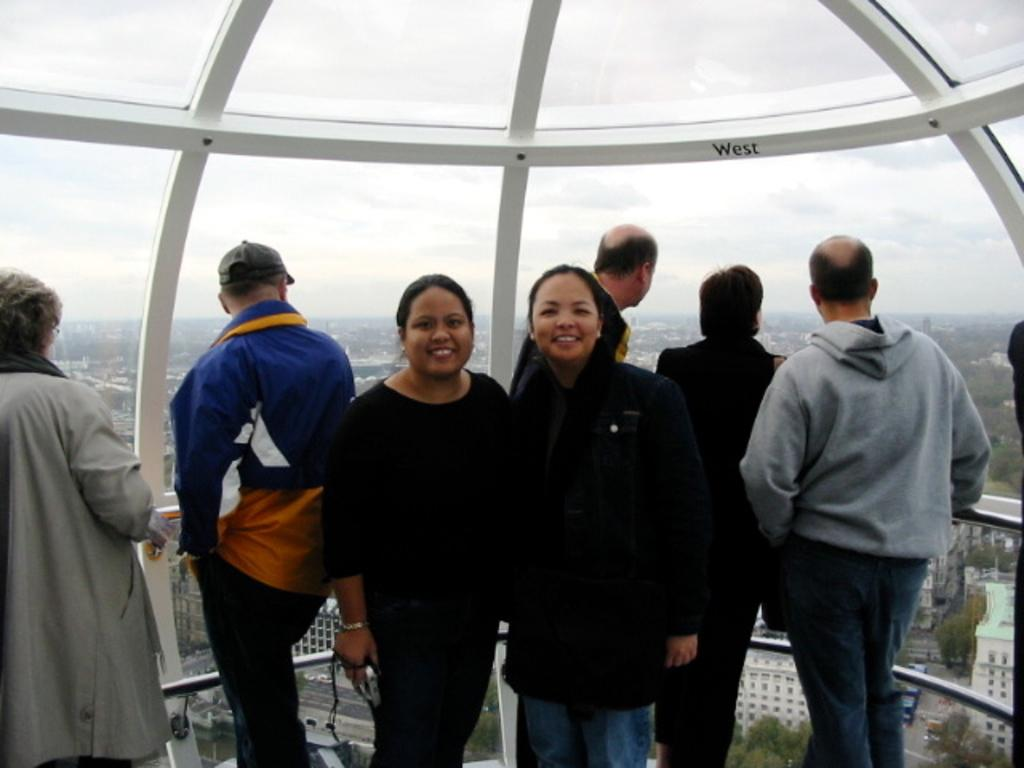How many people can be seen in the image? There are many people standing in the image. What is the lady holding in the image? The lady is holding a camera. Can you describe the person behind the lady? A person is wearing a cap behind the lady. What can be seen in the background of the image? There are buildings, trees, and the sky visible in the background of the image. What type of furniture is being discussed in the meeting in the image? There is no meeting or furniture present in the image. Can you describe the elbow of the person wearing the cap? There is no visible elbow of the person wearing the cap in the image. 